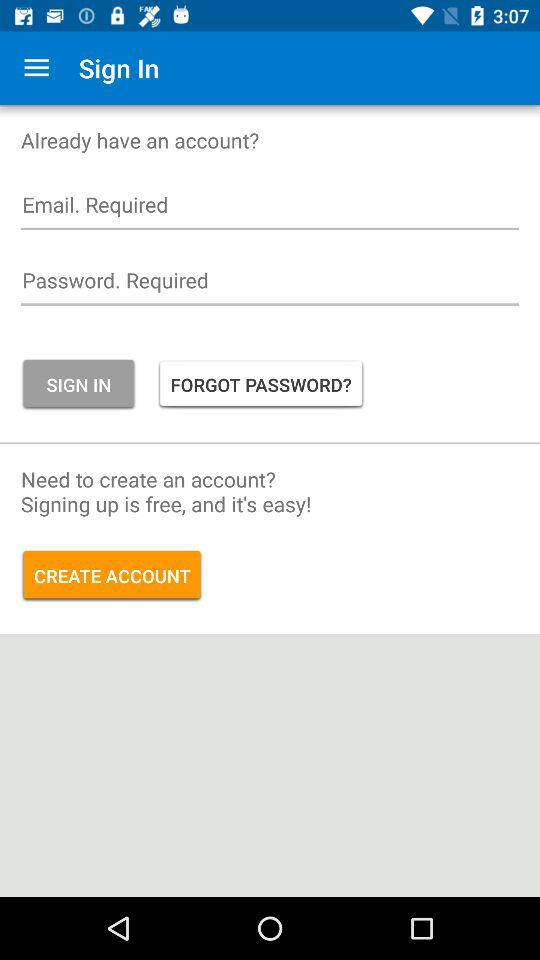How many text inputs are required to sign in?
Answer the question using a single word or phrase. 2 